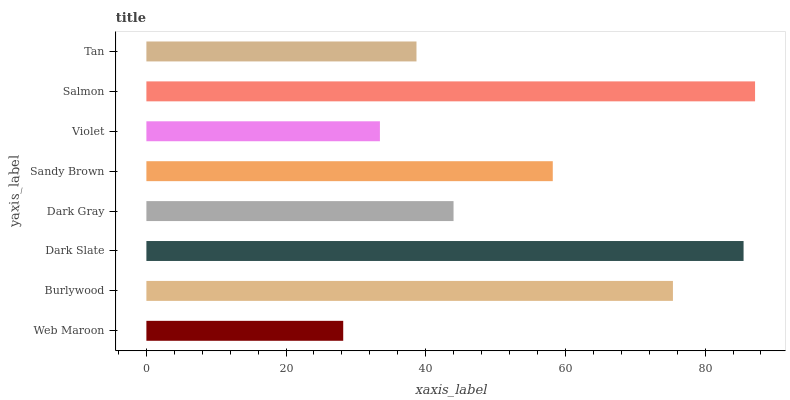Is Web Maroon the minimum?
Answer yes or no. Yes. Is Salmon the maximum?
Answer yes or no. Yes. Is Burlywood the minimum?
Answer yes or no. No. Is Burlywood the maximum?
Answer yes or no. No. Is Burlywood greater than Web Maroon?
Answer yes or no. Yes. Is Web Maroon less than Burlywood?
Answer yes or no. Yes. Is Web Maroon greater than Burlywood?
Answer yes or no. No. Is Burlywood less than Web Maroon?
Answer yes or no. No. Is Sandy Brown the high median?
Answer yes or no. Yes. Is Dark Gray the low median?
Answer yes or no. Yes. Is Violet the high median?
Answer yes or no. No. Is Violet the low median?
Answer yes or no. No. 